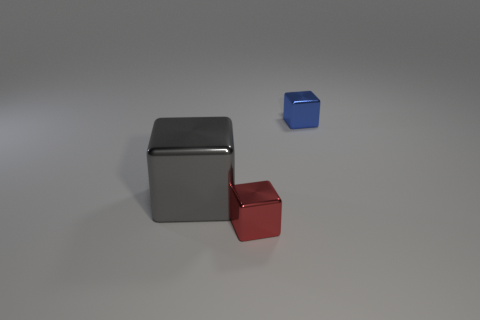Add 3 big gray metal things. How many objects exist? 6 Subtract all small blue metallic blocks. Subtract all large cubes. How many objects are left? 1 Add 2 tiny red metallic cubes. How many tiny red metallic cubes are left? 3 Add 1 tiny blue shiny objects. How many tiny blue shiny objects exist? 2 Subtract 0 gray cylinders. How many objects are left? 3 